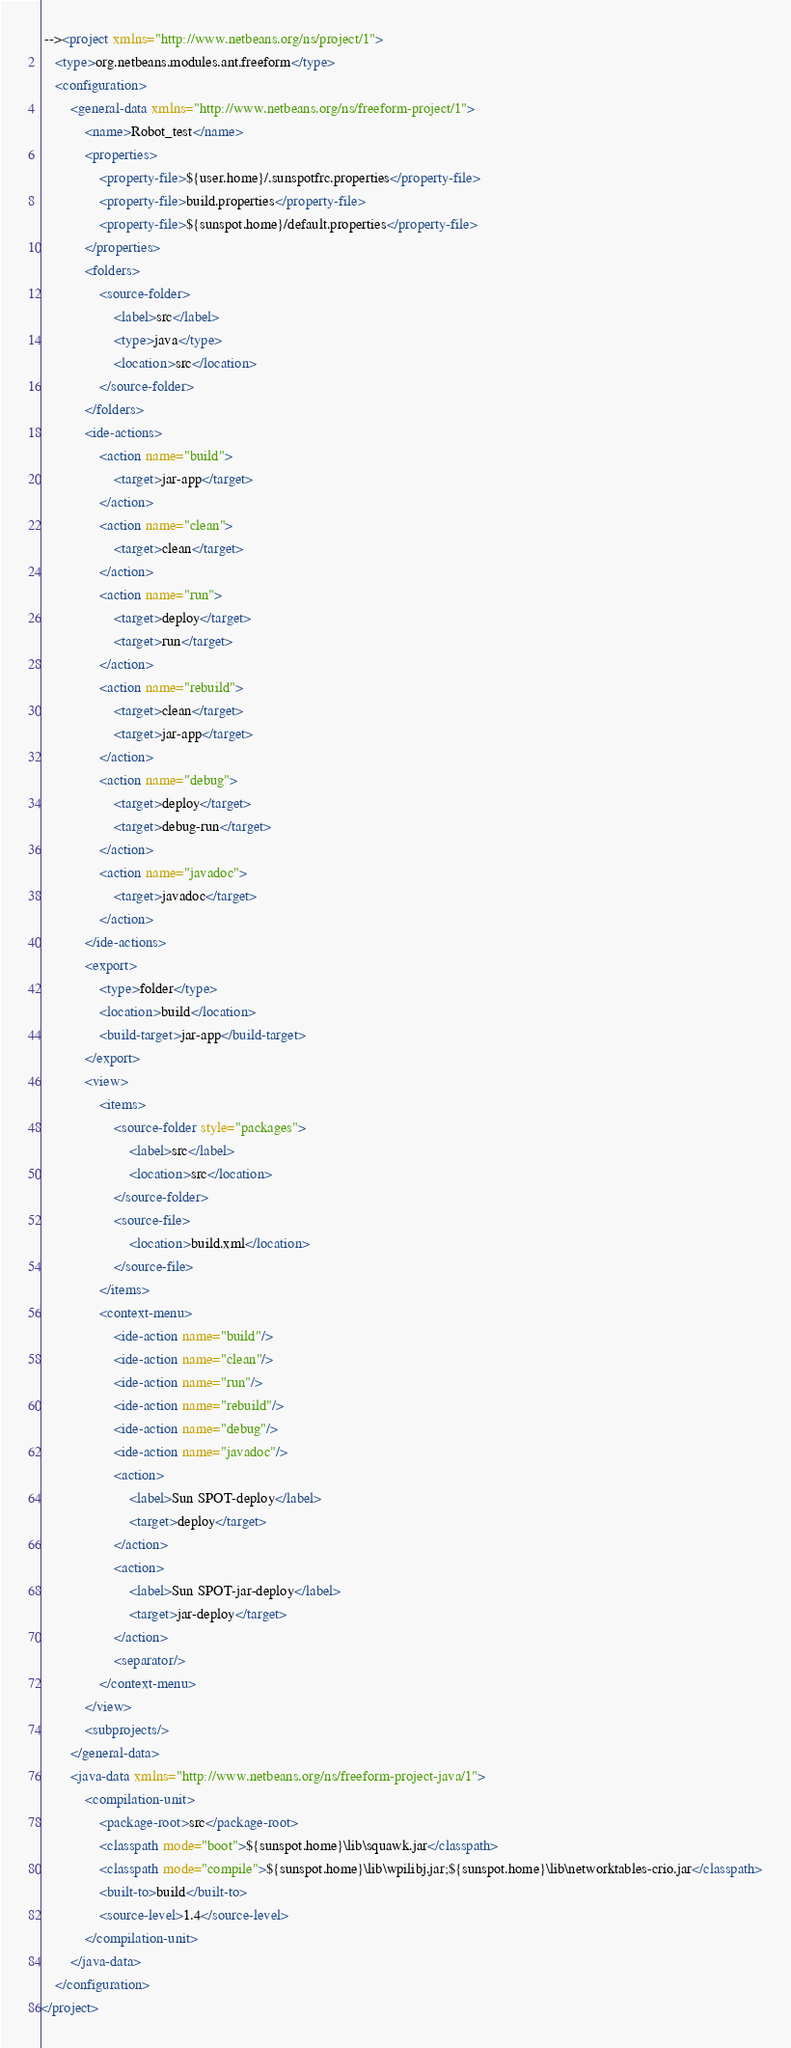Convert code to text. <code><loc_0><loc_0><loc_500><loc_500><_XML_> --><project xmlns="http://www.netbeans.org/ns/project/1">
    <type>org.netbeans.modules.ant.freeform</type>
    <configuration>
        <general-data xmlns="http://www.netbeans.org/ns/freeform-project/1">
            <name>Robot_test</name>
            <properties>
                <property-file>${user.home}/.sunspotfrc.properties</property-file>
                <property-file>build.properties</property-file>
                <property-file>${sunspot.home}/default.properties</property-file>
            </properties>
            <folders>
                <source-folder>
                    <label>src</label>
                    <type>java</type>
                    <location>src</location>
                </source-folder>
            </folders>
            <ide-actions>
                <action name="build">
                    <target>jar-app</target>
                </action>
                <action name="clean">
                    <target>clean</target>
                </action>
                <action name="run">
                    <target>deploy</target>
                    <target>run</target>
                </action>
                <action name="rebuild">
                    <target>clean</target>
                    <target>jar-app</target>
                </action>
                <action name="debug">
                    <target>deploy</target>
                    <target>debug-run</target>
                </action>
                <action name="javadoc">
                    <target>javadoc</target>
                </action>
            </ide-actions>
            <export>
                <type>folder</type>
                <location>build</location>
                <build-target>jar-app</build-target>
            </export>
            <view>
                <items>
                    <source-folder style="packages">
                        <label>src</label>
                        <location>src</location>
                    </source-folder>
                    <source-file>
                        <location>build.xml</location>
                    </source-file>
                </items>
                <context-menu>
                    <ide-action name="build"/>
                    <ide-action name="clean"/>
                    <ide-action name="run"/>
                    <ide-action name="rebuild"/>
                    <ide-action name="debug"/>
                    <ide-action name="javadoc"/>
                    <action>
                        <label>Sun SPOT-deploy</label>
                        <target>deploy</target>
                    </action>
                    <action>
                        <label>Sun SPOT-jar-deploy</label>
                        <target>jar-deploy</target>
                    </action>
                    <separator/>
                </context-menu>
            </view>
            <subprojects/>
        </general-data>
        <java-data xmlns="http://www.netbeans.org/ns/freeform-project-java/1">
            <compilation-unit>
                <package-root>src</package-root>
                <classpath mode="boot">${sunspot.home}\lib\squawk.jar</classpath>
                <classpath mode="compile">${sunspot.home}\lib\wpilibj.jar;${sunspot.home}\lib\networktables-crio.jar</classpath>
                <built-to>build</built-to>
                <source-level>1.4</source-level>
            </compilation-unit>
        </java-data>
    </configuration>
</project>
</code> 